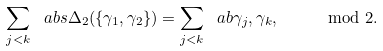<formula> <loc_0><loc_0><loc_500><loc_500>\sum _ { j < k } \ a b s { \Delta _ { 2 } ( \{ \gamma _ { 1 } , \gamma _ { 2 } \} ) } = \sum _ { j < k } \ a b { \gamma _ { j } , \gamma _ { k } } , \quad \mod 2 .</formula> 